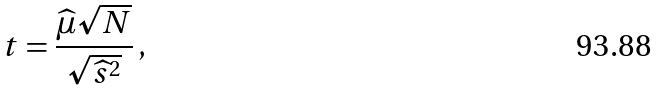<formula> <loc_0><loc_0><loc_500><loc_500>t = \frac { \widehat { \mu } \sqrt { N } } { \sqrt { \widehat { s } ^ { 2 } } } \, ,</formula> 